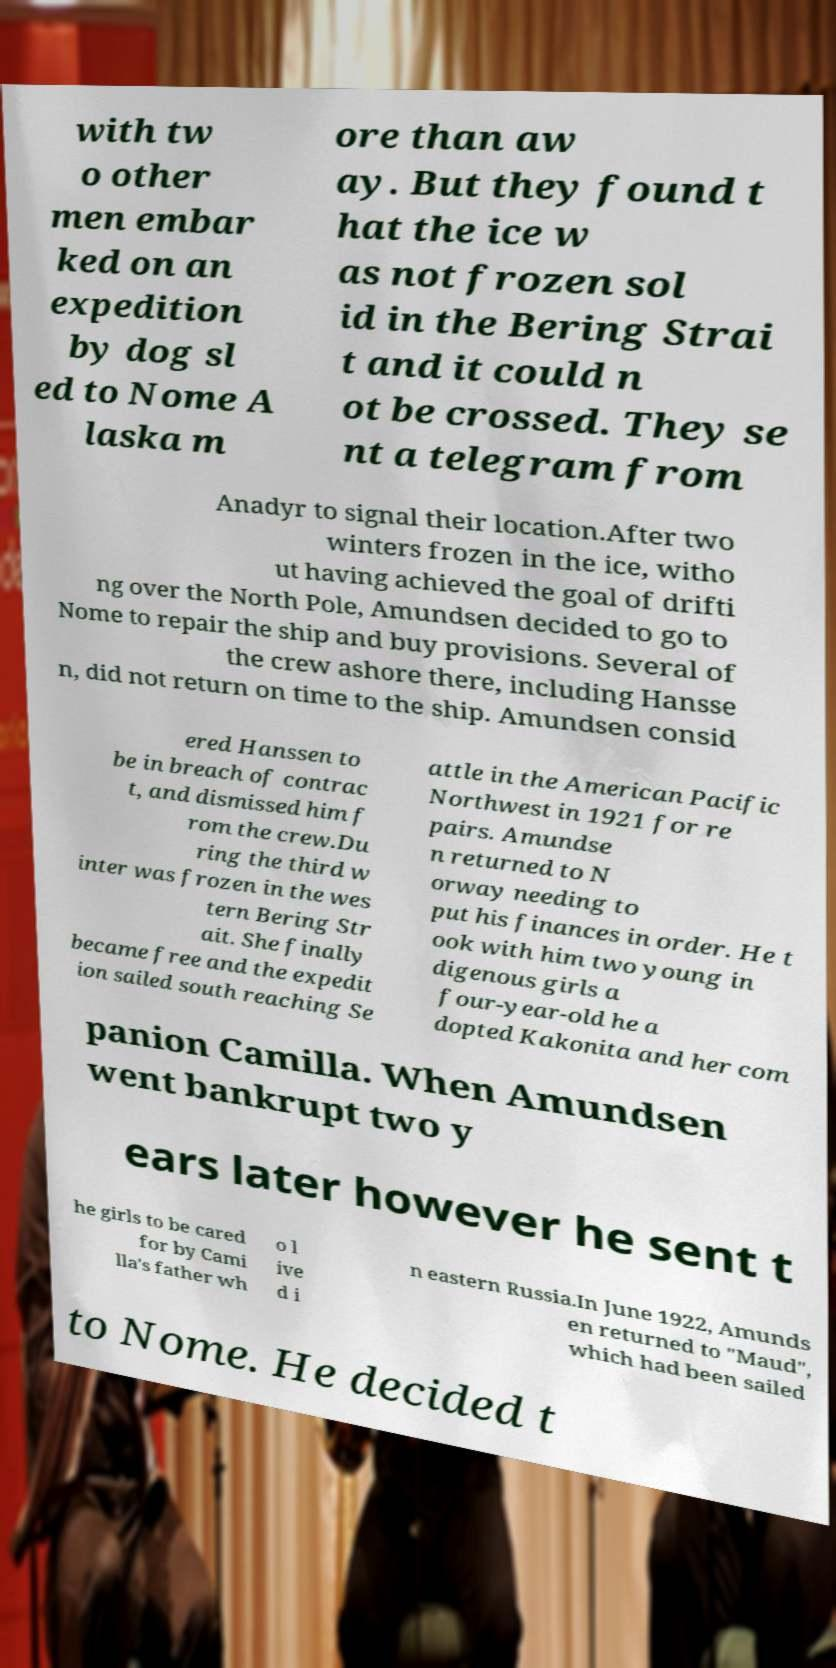Please identify and transcribe the text found in this image. with tw o other men embar ked on an expedition by dog sl ed to Nome A laska m ore than aw ay. But they found t hat the ice w as not frozen sol id in the Bering Strai t and it could n ot be crossed. They se nt a telegram from Anadyr to signal their location.After two winters frozen in the ice, witho ut having achieved the goal of drifti ng over the North Pole, Amundsen decided to go to Nome to repair the ship and buy provisions. Several of the crew ashore there, including Hansse n, did not return on time to the ship. Amundsen consid ered Hanssen to be in breach of contrac t, and dismissed him f rom the crew.Du ring the third w inter was frozen in the wes tern Bering Str ait. She finally became free and the expedit ion sailed south reaching Se attle in the American Pacific Northwest in 1921 for re pairs. Amundse n returned to N orway needing to put his finances in order. He t ook with him two young in digenous girls a four-year-old he a dopted Kakonita and her com panion Camilla. When Amundsen went bankrupt two y ears later however he sent t he girls to be cared for by Cami lla's father wh o l ive d i n eastern Russia.In June 1922, Amunds en returned to "Maud", which had been sailed to Nome. He decided t 